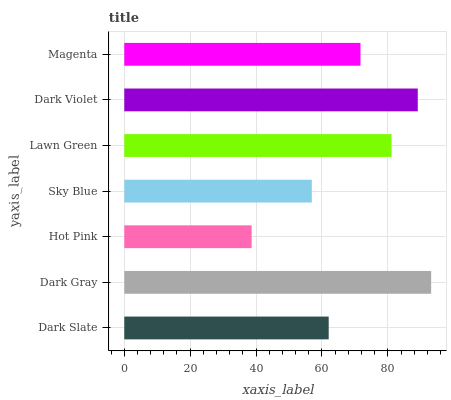Is Hot Pink the minimum?
Answer yes or no. Yes. Is Dark Gray the maximum?
Answer yes or no. Yes. Is Dark Gray the minimum?
Answer yes or no. No. Is Hot Pink the maximum?
Answer yes or no. No. Is Dark Gray greater than Hot Pink?
Answer yes or no. Yes. Is Hot Pink less than Dark Gray?
Answer yes or no. Yes. Is Hot Pink greater than Dark Gray?
Answer yes or no. No. Is Dark Gray less than Hot Pink?
Answer yes or no. No. Is Magenta the high median?
Answer yes or no. Yes. Is Magenta the low median?
Answer yes or no. Yes. Is Hot Pink the high median?
Answer yes or no. No. Is Lawn Green the low median?
Answer yes or no. No. 